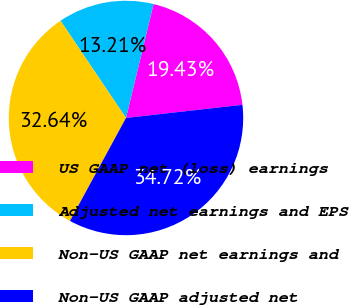<chart> <loc_0><loc_0><loc_500><loc_500><pie_chart><fcel>US GAAP net (loss) earnings<fcel>Adjusted net earnings and EPS<fcel>Non-US GAAP net earnings and<fcel>Non-US GAAP adjusted net<nl><fcel>19.43%<fcel>13.21%<fcel>32.64%<fcel>34.72%<nl></chart> 